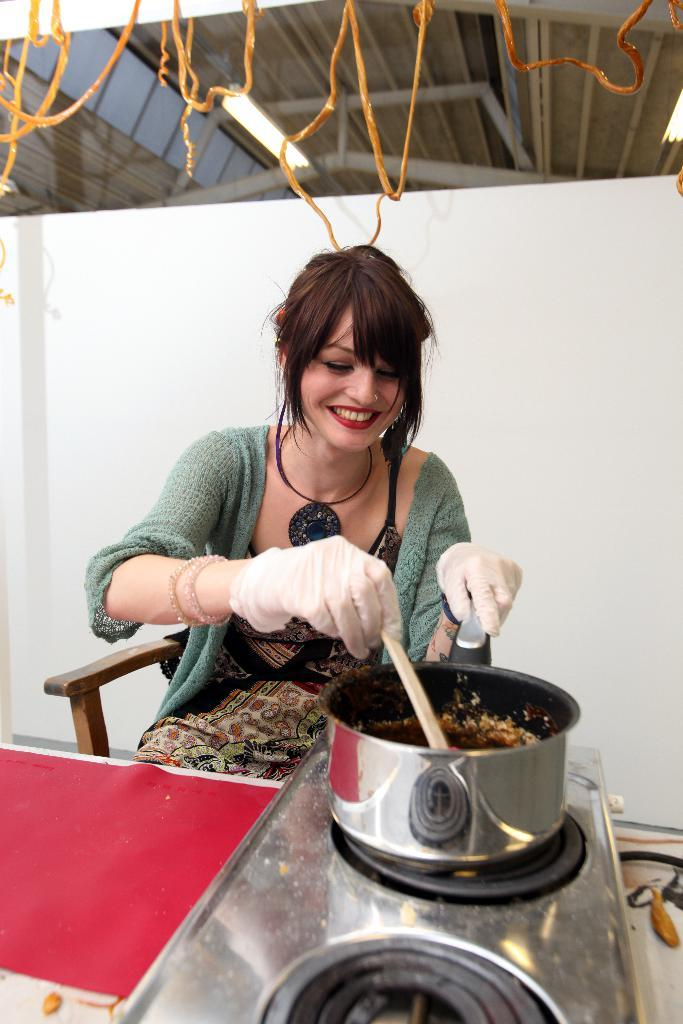What is the woman doing in the image? She is sitting in a chair and preparing something, possibly a food item. What is she holding in her hand? She is holding a spoon. What is she wearing on her hands? She is wearing gloves. What is her facial expression in the image? She is smiling. What time of day is it in the image, and how does she react to the surprise snowfall? There is no mention of time of day or snowfall in the image, so we cannot determine the hour or her reaction to a surprise snowfall. 